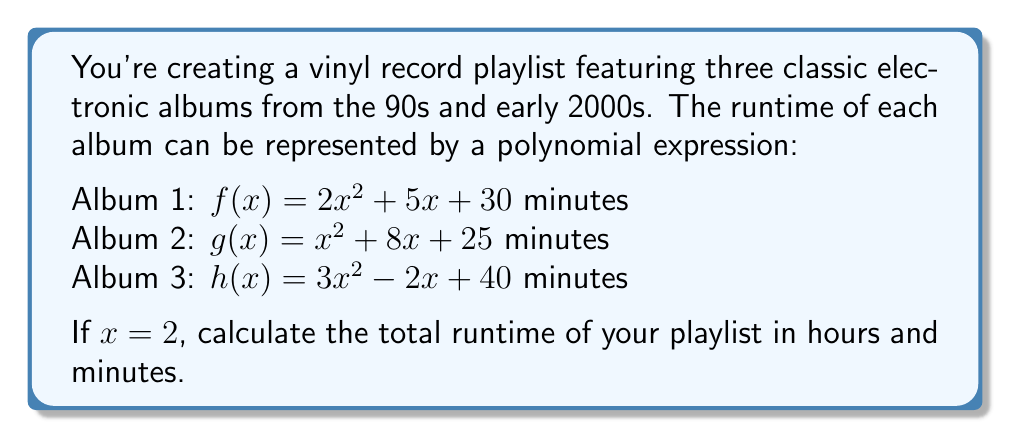Help me with this question. To solve this problem, we need to follow these steps:

1. Evaluate each polynomial expression for $x = 2$
2. Sum up the results to get the total runtime in minutes
3. Convert the total minutes to hours and minutes

Let's start:

1. Evaluating each polynomial:

   For Album 1: $f(2) = 2(2)^2 + 5(2) + 30$
              $= 2(4) + 10 + 30$
              $= 8 + 10 + 30 = 48$ minutes

   For Album 2: $g(2) = (2)^2 + 8(2) + 25$
              $= 4 + 16 + 25 = 45$ minutes

   For Album 3: $h(2) = 3(2)^2 - 2(2) + 40$
              $= 3(4) - 4 + 40$
              $= 12 - 4 + 40 = 48$ minutes

2. Summing up the results:
   Total runtime = $48 + 45 + 48 = 141$ minutes

3. Converting 141 minutes to hours and minutes:
   $141 \div 60 = 2$ remainder $21$

Therefore, the total runtime is 2 hours and 21 minutes.
Answer: 2 hours and 21 minutes 